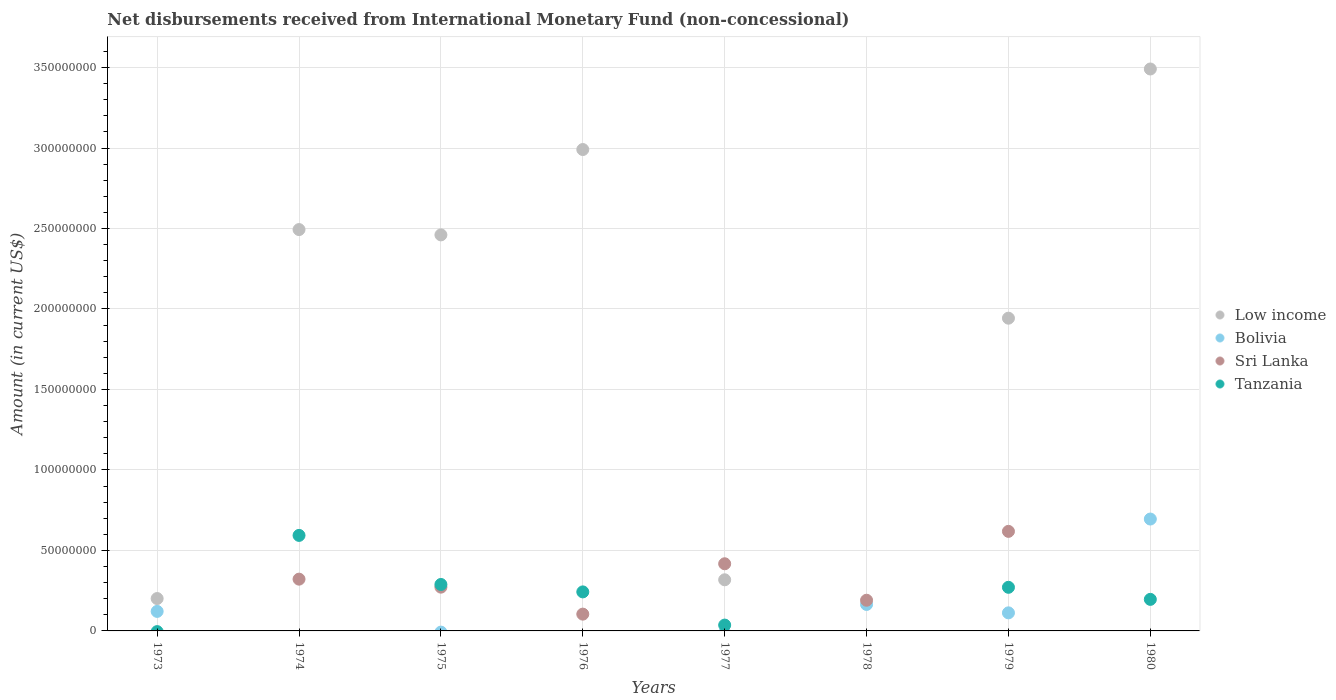How many different coloured dotlines are there?
Provide a succinct answer. 4. Is the number of dotlines equal to the number of legend labels?
Your answer should be very brief. No. What is the amount of disbursements received from International Monetary Fund in Bolivia in 1979?
Offer a terse response. 1.12e+07. Across all years, what is the maximum amount of disbursements received from International Monetary Fund in Bolivia?
Provide a short and direct response. 6.95e+07. In which year was the amount of disbursements received from International Monetary Fund in Bolivia maximum?
Give a very brief answer. 1980. What is the total amount of disbursements received from International Monetary Fund in Tanzania in the graph?
Provide a short and direct response. 1.63e+08. What is the difference between the amount of disbursements received from International Monetary Fund in Low income in 1974 and that in 1976?
Give a very brief answer. -4.97e+07. What is the difference between the amount of disbursements received from International Monetary Fund in Sri Lanka in 1973 and the amount of disbursements received from International Monetary Fund in Tanzania in 1976?
Provide a short and direct response. -2.42e+07. What is the average amount of disbursements received from International Monetary Fund in Bolivia per year?
Offer a very short reply. 1.37e+07. In the year 1978, what is the difference between the amount of disbursements received from International Monetary Fund in Sri Lanka and amount of disbursements received from International Monetary Fund in Bolivia?
Provide a succinct answer. 2.61e+06. What is the ratio of the amount of disbursements received from International Monetary Fund in Tanzania in 1974 to that in 1980?
Offer a very short reply. 3.03. What is the difference between the highest and the second highest amount of disbursements received from International Monetary Fund in Tanzania?
Make the answer very short. 3.05e+07. What is the difference between the highest and the lowest amount of disbursements received from International Monetary Fund in Bolivia?
Your answer should be very brief. 6.95e+07. Is the sum of the amount of disbursements received from International Monetary Fund in Low income in 1975 and 1980 greater than the maximum amount of disbursements received from International Monetary Fund in Tanzania across all years?
Provide a short and direct response. Yes. Is it the case that in every year, the sum of the amount of disbursements received from International Monetary Fund in Bolivia and amount of disbursements received from International Monetary Fund in Low income  is greater than the amount of disbursements received from International Monetary Fund in Sri Lanka?
Keep it short and to the point. No. Is the amount of disbursements received from International Monetary Fund in Bolivia strictly less than the amount of disbursements received from International Monetary Fund in Low income over the years?
Offer a very short reply. No. How many dotlines are there?
Provide a short and direct response. 4. What is the difference between two consecutive major ticks on the Y-axis?
Your answer should be very brief. 5.00e+07. Does the graph contain any zero values?
Provide a short and direct response. Yes. Does the graph contain grids?
Your answer should be compact. Yes. Where does the legend appear in the graph?
Offer a very short reply. Center right. What is the title of the graph?
Ensure brevity in your answer.  Net disbursements received from International Monetary Fund (non-concessional). What is the Amount (in current US$) in Low income in 1973?
Your response must be concise. 2.01e+07. What is the Amount (in current US$) in Bolivia in 1973?
Offer a terse response. 1.21e+07. What is the Amount (in current US$) in Sri Lanka in 1973?
Your answer should be very brief. 0. What is the Amount (in current US$) of Low income in 1974?
Make the answer very short. 2.49e+08. What is the Amount (in current US$) in Bolivia in 1974?
Your answer should be very brief. 0. What is the Amount (in current US$) of Sri Lanka in 1974?
Offer a very short reply. 3.22e+07. What is the Amount (in current US$) in Tanzania in 1974?
Provide a short and direct response. 5.93e+07. What is the Amount (in current US$) in Low income in 1975?
Make the answer very short. 2.46e+08. What is the Amount (in current US$) of Sri Lanka in 1975?
Give a very brief answer. 2.72e+07. What is the Amount (in current US$) in Tanzania in 1975?
Provide a succinct answer. 2.89e+07. What is the Amount (in current US$) in Low income in 1976?
Your answer should be compact. 2.99e+08. What is the Amount (in current US$) in Sri Lanka in 1976?
Give a very brief answer. 1.04e+07. What is the Amount (in current US$) of Tanzania in 1976?
Offer a very short reply. 2.42e+07. What is the Amount (in current US$) in Low income in 1977?
Give a very brief answer. 3.18e+07. What is the Amount (in current US$) in Bolivia in 1977?
Make the answer very short. 0. What is the Amount (in current US$) of Sri Lanka in 1977?
Provide a short and direct response. 4.17e+07. What is the Amount (in current US$) in Tanzania in 1977?
Your answer should be very brief. 3.63e+06. What is the Amount (in current US$) in Bolivia in 1978?
Offer a very short reply. 1.64e+07. What is the Amount (in current US$) of Sri Lanka in 1978?
Give a very brief answer. 1.91e+07. What is the Amount (in current US$) of Tanzania in 1978?
Provide a succinct answer. 0. What is the Amount (in current US$) in Low income in 1979?
Offer a terse response. 1.94e+08. What is the Amount (in current US$) in Bolivia in 1979?
Your response must be concise. 1.12e+07. What is the Amount (in current US$) in Sri Lanka in 1979?
Your answer should be compact. 6.18e+07. What is the Amount (in current US$) in Tanzania in 1979?
Provide a succinct answer. 2.71e+07. What is the Amount (in current US$) in Low income in 1980?
Provide a succinct answer. 3.49e+08. What is the Amount (in current US$) of Bolivia in 1980?
Your answer should be compact. 6.95e+07. What is the Amount (in current US$) in Tanzania in 1980?
Give a very brief answer. 1.96e+07. Across all years, what is the maximum Amount (in current US$) of Low income?
Give a very brief answer. 3.49e+08. Across all years, what is the maximum Amount (in current US$) in Bolivia?
Provide a succinct answer. 6.95e+07. Across all years, what is the maximum Amount (in current US$) in Sri Lanka?
Provide a succinct answer. 6.18e+07. Across all years, what is the maximum Amount (in current US$) in Tanzania?
Ensure brevity in your answer.  5.93e+07. Across all years, what is the minimum Amount (in current US$) in Low income?
Give a very brief answer. 0. Across all years, what is the minimum Amount (in current US$) of Bolivia?
Make the answer very short. 0. Across all years, what is the minimum Amount (in current US$) in Sri Lanka?
Provide a short and direct response. 0. Across all years, what is the minimum Amount (in current US$) of Tanzania?
Your answer should be very brief. 0. What is the total Amount (in current US$) of Low income in the graph?
Offer a very short reply. 1.39e+09. What is the total Amount (in current US$) in Bolivia in the graph?
Provide a succinct answer. 1.09e+08. What is the total Amount (in current US$) of Sri Lanka in the graph?
Offer a very short reply. 1.92e+08. What is the total Amount (in current US$) in Tanzania in the graph?
Ensure brevity in your answer.  1.63e+08. What is the difference between the Amount (in current US$) of Low income in 1973 and that in 1974?
Give a very brief answer. -2.29e+08. What is the difference between the Amount (in current US$) of Low income in 1973 and that in 1975?
Provide a succinct answer. -2.26e+08. What is the difference between the Amount (in current US$) of Low income in 1973 and that in 1976?
Ensure brevity in your answer.  -2.79e+08. What is the difference between the Amount (in current US$) of Low income in 1973 and that in 1977?
Offer a terse response. -1.17e+07. What is the difference between the Amount (in current US$) of Bolivia in 1973 and that in 1978?
Offer a very short reply. -4.32e+06. What is the difference between the Amount (in current US$) in Low income in 1973 and that in 1979?
Keep it short and to the point. -1.74e+08. What is the difference between the Amount (in current US$) in Bolivia in 1973 and that in 1979?
Your response must be concise. 8.99e+05. What is the difference between the Amount (in current US$) in Low income in 1973 and that in 1980?
Make the answer very short. -3.29e+08. What is the difference between the Amount (in current US$) in Bolivia in 1973 and that in 1980?
Offer a terse response. -5.74e+07. What is the difference between the Amount (in current US$) in Low income in 1974 and that in 1975?
Your response must be concise. 3.30e+06. What is the difference between the Amount (in current US$) in Sri Lanka in 1974 and that in 1975?
Offer a terse response. 4.97e+06. What is the difference between the Amount (in current US$) of Tanzania in 1974 and that in 1975?
Ensure brevity in your answer.  3.05e+07. What is the difference between the Amount (in current US$) of Low income in 1974 and that in 1976?
Provide a short and direct response. -4.97e+07. What is the difference between the Amount (in current US$) in Sri Lanka in 1974 and that in 1976?
Offer a terse response. 2.17e+07. What is the difference between the Amount (in current US$) in Tanzania in 1974 and that in 1976?
Your answer should be very brief. 3.51e+07. What is the difference between the Amount (in current US$) of Low income in 1974 and that in 1977?
Give a very brief answer. 2.18e+08. What is the difference between the Amount (in current US$) in Sri Lanka in 1974 and that in 1977?
Give a very brief answer. -9.56e+06. What is the difference between the Amount (in current US$) of Tanzania in 1974 and that in 1977?
Your answer should be compact. 5.57e+07. What is the difference between the Amount (in current US$) of Sri Lanka in 1974 and that in 1978?
Offer a terse response. 1.31e+07. What is the difference between the Amount (in current US$) in Low income in 1974 and that in 1979?
Provide a succinct answer. 5.50e+07. What is the difference between the Amount (in current US$) of Sri Lanka in 1974 and that in 1979?
Offer a terse response. -2.97e+07. What is the difference between the Amount (in current US$) in Tanzania in 1974 and that in 1979?
Provide a succinct answer. 3.22e+07. What is the difference between the Amount (in current US$) of Low income in 1974 and that in 1980?
Make the answer very short. -9.98e+07. What is the difference between the Amount (in current US$) in Tanzania in 1974 and that in 1980?
Your response must be concise. 3.97e+07. What is the difference between the Amount (in current US$) of Low income in 1975 and that in 1976?
Your answer should be very brief. -5.30e+07. What is the difference between the Amount (in current US$) of Sri Lanka in 1975 and that in 1976?
Provide a succinct answer. 1.68e+07. What is the difference between the Amount (in current US$) in Tanzania in 1975 and that in 1976?
Your response must be concise. 4.61e+06. What is the difference between the Amount (in current US$) in Low income in 1975 and that in 1977?
Ensure brevity in your answer.  2.14e+08. What is the difference between the Amount (in current US$) in Sri Lanka in 1975 and that in 1977?
Keep it short and to the point. -1.45e+07. What is the difference between the Amount (in current US$) of Tanzania in 1975 and that in 1977?
Offer a very short reply. 2.52e+07. What is the difference between the Amount (in current US$) in Sri Lanka in 1975 and that in 1978?
Your answer should be very brief. 8.14e+06. What is the difference between the Amount (in current US$) in Low income in 1975 and that in 1979?
Your answer should be compact. 5.17e+07. What is the difference between the Amount (in current US$) in Sri Lanka in 1975 and that in 1979?
Keep it short and to the point. -3.47e+07. What is the difference between the Amount (in current US$) in Tanzania in 1975 and that in 1979?
Give a very brief answer. 1.76e+06. What is the difference between the Amount (in current US$) of Low income in 1975 and that in 1980?
Keep it short and to the point. -1.03e+08. What is the difference between the Amount (in current US$) of Tanzania in 1975 and that in 1980?
Offer a terse response. 9.26e+06. What is the difference between the Amount (in current US$) of Low income in 1976 and that in 1977?
Provide a succinct answer. 2.67e+08. What is the difference between the Amount (in current US$) in Sri Lanka in 1976 and that in 1977?
Give a very brief answer. -3.13e+07. What is the difference between the Amount (in current US$) of Tanzania in 1976 and that in 1977?
Your answer should be very brief. 2.06e+07. What is the difference between the Amount (in current US$) of Sri Lanka in 1976 and that in 1978?
Offer a terse response. -8.63e+06. What is the difference between the Amount (in current US$) in Low income in 1976 and that in 1979?
Your answer should be very brief. 1.05e+08. What is the difference between the Amount (in current US$) of Sri Lanka in 1976 and that in 1979?
Your answer should be compact. -5.14e+07. What is the difference between the Amount (in current US$) in Tanzania in 1976 and that in 1979?
Provide a short and direct response. -2.85e+06. What is the difference between the Amount (in current US$) of Low income in 1976 and that in 1980?
Your answer should be compact. -5.00e+07. What is the difference between the Amount (in current US$) of Tanzania in 1976 and that in 1980?
Your response must be concise. 4.64e+06. What is the difference between the Amount (in current US$) of Sri Lanka in 1977 and that in 1978?
Your answer should be very brief. 2.27e+07. What is the difference between the Amount (in current US$) in Low income in 1977 and that in 1979?
Your response must be concise. -1.63e+08. What is the difference between the Amount (in current US$) of Sri Lanka in 1977 and that in 1979?
Your answer should be very brief. -2.01e+07. What is the difference between the Amount (in current US$) in Tanzania in 1977 and that in 1979?
Keep it short and to the point. -2.35e+07. What is the difference between the Amount (in current US$) in Low income in 1977 and that in 1980?
Keep it short and to the point. -3.17e+08. What is the difference between the Amount (in current US$) in Tanzania in 1977 and that in 1980?
Your answer should be compact. -1.60e+07. What is the difference between the Amount (in current US$) of Bolivia in 1978 and that in 1979?
Your answer should be very brief. 5.22e+06. What is the difference between the Amount (in current US$) in Sri Lanka in 1978 and that in 1979?
Offer a terse response. -4.28e+07. What is the difference between the Amount (in current US$) of Bolivia in 1978 and that in 1980?
Ensure brevity in your answer.  -5.31e+07. What is the difference between the Amount (in current US$) of Low income in 1979 and that in 1980?
Provide a short and direct response. -1.55e+08. What is the difference between the Amount (in current US$) of Bolivia in 1979 and that in 1980?
Ensure brevity in your answer.  -5.83e+07. What is the difference between the Amount (in current US$) of Tanzania in 1979 and that in 1980?
Make the answer very short. 7.50e+06. What is the difference between the Amount (in current US$) in Low income in 1973 and the Amount (in current US$) in Sri Lanka in 1974?
Keep it short and to the point. -1.20e+07. What is the difference between the Amount (in current US$) of Low income in 1973 and the Amount (in current US$) of Tanzania in 1974?
Give a very brief answer. -3.92e+07. What is the difference between the Amount (in current US$) in Bolivia in 1973 and the Amount (in current US$) in Sri Lanka in 1974?
Offer a very short reply. -2.00e+07. What is the difference between the Amount (in current US$) of Bolivia in 1973 and the Amount (in current US$) of Tanzania in 1974?
Your response must be concise. -4.72e+07. What is the difference between the Amount (in current US$) in Low income in 1973 and the Amount (in current US$) in Sri Lanka in 1975?
Your answer should be very brief. -7.08e+06. What is the difference between the Amount (in current US$) in Low income in 1973 and the Amount (in current US$) in Tanzania in 1975?
Provide a short and direct response. -8.74e+06. What is the difference between the Amount (in current US$) of Bolivia in 1973 and the Amount (in current US$) of Sri Lanka in 1975?
Your answer should be compact. -1.51e+07. What is the difference between the Amount (in current US$) in Bolivia in 1973 and the Amount (in current US$) in Tanzania in 1975?
Provide a succinct answer. -1.67e+07. What is the difference between the Amount (in current US$) of Low income in 1973 and the Amount (in current US$) of Sri Lanka in 1976?
Your answer should be very brief. 9.68e+06. What is the difference between the Amount (in current US$) of Low income in 1973 and the Amount (in current US$) of Tanzania in 1976?
Your answer should be compact. -4.13e+06. What is the difference between the Amount (in current US$) of Bolivia in 1973 and the Amount (in current US$) of Sri Lanka in 1976?
Provide a succinct answer. 1.70e+06. What is the difference between the Amount (in current US$) in Bolivia in 1973 and the Amount (in current US$) in Tanzania in 1976?
Provide a short and direct response. -1.21e+07. What is the difference between the Amount (in current US$) in Low income in 1973 and the Amount (in current US$) in Sri Lanka in 1977?
Provide a short and direct response. -2.16e+07. What is the difference between the Amount (in current US$) in Low income in 1973 and the Amount (in current US$) in Tanzania in 1977?
Your answer should be compact. 1.65e+07. What is the difference between the Amount (in current US$) in Bolivia in 1973 and the Amount (in current US$) in Sri Lanka in 1977?
Your answer should be compact. -2.96e+07. What is the difference between the Amount (in current US$) in Bolivia in 1973 and the Amount (in current US$) in Tanzania in 1977?
Make the answer very short. 8.50e+06. What is the difference between the Amount (in current US$) in Low income in 1973 and the Amount (in current US$) in Bolivia in 1978?
Keep it short and to the point. 3.67e+06. What is the difference between the Amount (in current US$) of Low income in 1973 and the Amount (in current US$) of Sri Lanka in 1978?
Offer a very short reply. 1.06e+06. What is the difference between the Amount (in current US$) of Bolivia in 1973 and the Amount (in current US$) of Sri Lanka in 1978?
Provide a succinct answer. -6.93e+06. What is the difference between the Amount (in current US$) in Low income in 1973 and the Amount (in current US$) in Bolivia in 1979?
Offer a very short reply. 8.88e+06. What is the difference between the Amount (in current US$) in Low income in 1973 and the Amount (in current US$) in Sri Lanka in 1979?
Offer a terse response. -4.17e+07. What is the difference between the Amount (in current US$) of Low income in 1973 and the Amount (in current US$) of Tanzania in 1979?
Provide a short and direct response. -6.98e+06. What is the difference between the Amount (in current US$) of Bolivia in 1973 and the Amount (in current US$) of Sri Lanka in 1979?
Offer a very short reply. -4.97e+07. What is the difference between the Amount (in current US$) of Bolivia in 1973 and the Amount (in current US$) of Tanzania in 1979?
Your answer should be very brief. -1.50e+07. What is the difference between the Amount (in current US$) of Low income in 1973 and the Amount (in current US$) of Bolivia in 1980?
Provide a short and direct response. -4.94e+07. What is the difference between the Amount (in current US$) in Low income in 1973 and the Amount (in current US$) in Tanzania in 1980?
Offer a very short reply. 5.13e+05. What is the difference between the Amount (in current US$) in Bolivia in 1973 and the Amount (in current US$) in Tanzania in 1980?
Provide a succinct answer. -7.47e+06. What is the difference between the Amount (in current US$) of Low income in 1974 and the Amount (in current US$) of Sri Lanka in 1975?
Your answer should be compact. 2.22e+08. What is the difference between the Amount (in current US$) in Low income in 1974 and the Amount (in current US$) in Tanzania in 1975?
Keep it short and to the point. 2.20e+08. What is the difference between the Amount (in current US$) in Sri Lanka in 1974 and the Amount (in current US$) in Tanzania in 1975?
Offer a terse response. 3.30e+06. What is the difference between the Amount (in current US$) in Low income in 1974 and the Amount (in current US$) in Sri Lanka in 1976?
Your answer should be very brief. 2.39e+08. What is the difference between the Amount (in current US$) of Low income in 1974 and the Amount (in current US$) of Tanzania in 1976?
Your answer should be very brief. 2.25e+08. What is the difference between the Amount (in current US$) in Sri Lanka in 1974 and the Amount (in current US$) in Tanzania in 1976?
Offer a very short reply. 7.92e+06. What is the difference between the Amount (in current US$) in Low income in 1974 and the Amount (in current US$) in Sri Lanka in 1977?
Give a very brief answer. 2.08e+08. What is the difference between the Amount (in current US$) in Low income in 1974 and the Amount (in current US$) in Tanzania in 1977?
Give a very brief answer. 2.46e+08. What is the difference between the Amount (in current US$) in Sri Lanka in 1974 and the Amount (in current US$) in Tanzania in 1977?
Offer a terse response. 2.85e+07. What is the difference between the Amount (in current US$) of Low income in 1974 and the Amount (in current US$) of Bolivia in 1978?
Offer a very short reply. 2.33e+08. What is the difference between the Amount (in current US$) of Low income in 1974 and the Amount (in current US$) of Sri Lanka in 1978?
Offer a terse response. 2.30e+08. What is the difference between the Amount (in current US$) of Low income in 1974 and the Amount (in current US$) of Bolivia in 1979?
Your answer should be compact. 2.38e+08. What is the difference between the Amount (in current US$) of Low income in 1974 and the Amount (in current US$) of Sri Lanka in 1979?
Give a very brief answer. 1.87e+08. What is the difference between the Amount (in current US$) in Low income in 1974 and the Amount (in current US$) in Tanzania in 1979?
Your response must be concise. 2.22e+08. What is the difference between the Amount (in current US$) in Sri Lanka in 1974 and the Amount (in current US$) in Tanzania in 1979?
Your response must be concise. 5.07e+06. What is the difference between the Amount (in current US$) of Low income in 1974 and the Amount (in current US$) of Bolivia in 1980?
Make the answer very short. 1.80e+08. What is the difference between the Amount (in current US$) of Low income in 1974 and the Amount (in current US$) of Tanzania in 1980?
Your answer should be compact. 2.30e+08. What is the difference between the Amount (in current US$) in Sri Lanka in 1974 and the Amount (in current US$) in Tanzania in 1980?
Your answer should be very brief. 1.26e+07. What is the difference between the Amount (in current US$) of Low income in 1975 and the Amount (in current US$) of Sri Lanka in 1976?
Provide a short and direct response. 2.36e+08. What is the difference between the Amount (in current US$) of Low income in 1975 and the Amount (in current US$) of Tanzania in 1976?
Offer a terse response. 2.22e+08. What is the difference between the Amount (in current US$) in Sri Lanka in 1975 and the Amount (in current US$) in Tanzania in 1976?
Offer a terse response. 2.95e+06. What is the difference between the Amount (in current US$) of Low income in 1975 and the Amount (in current US$) of Sri Lanka in 1977?
Your answer should be very brief. 2.04e+08. What is the difference between the Amount (in current US$) of Low income in 1975 and the Amount (in current US$) of Tanzania in 1977?
Your response must be concise. 2.42e+08. What is the difference between the Amount (in current US$) in Sri Lanka in 1975 and the Amount (in current US$) in Tanzania in 1977?
Your answer should be very brief. 2.36e+07. What is the difference between the Amount (in current US$) of Low income in 1975 and the Amount (in current US$) of Bolivia in 1978?
Make the answer very short. 2.30e+08. What is the difference between the Amount (in current US$) in Low income in 1975 and the Amount (in current US$) in Sri Lanka in 1978?
Offer a terse response. 2.27e+08. What is the difference between the Amount (in current US$) in Low income in 1975 and the Amount (in current US$) in Bolivia in 1979?
Provide a succinct answer. 2.35e+08. What is the difference between the Amount (in current US$) of Low income in 1975 and the Amount (in current US$) of Sri Lanka in 1979?
Offer a terse response. 1.84e+08. What is the difference between the Amount (in current US$) of Low income in 1975 and the Amount (in current US$) of Tanzania in 1979?
Offer a very short reply. 2.19e+08. What is the difference between the Amount (in current US$) in Sri Lanka in 1975 and the Amount (in current US$) in Tanzania in 1979?
Ensure brevity in your answer.  9.80e+04. What is the difference between the Amount (in current US$) of Low income in 1975 and the Amount (in current US$) of Bolivia in 1980?
Your answer should be compact. 1.77e+08. What is the difference between the Amount (in current US$) of Low income in 1975 and the Amount (in current US$) of Tanzania in 1980?
Keep it short and to the point. 2.26e+08. What is the difference between the Amount (in current US$) of Sri Lanka in 1975 and the Amount (in current US$) of Tanzania in 1980?
Make the answer very short. 7.59e+06. What is the difference between the Amount (in current US$) in Low income in 1976 and the Amount (in current US$) in Sri Lanka in 1977?
Offer a very short reply. 2.57e+08. What is the difference between the Amount (in current US$) in Low income in 1976 and the Amount (in current US$) in Tanzania in 1977?
Offer a very short reply. 2.95e+08. What is the difference between the Amount (in current US$) in Sri Lanka in 1976 and the Amount (in current US$) in Tanzania in 1977?
Keep it short and to the point. 6.80e+06. What is the difference between the Amount (in current US$) in Low income in 1976 and the Amount (in current US$) in Bolivia in 1978?
Your answer should be compact. 2.83e+08. What is the difference between the Amount (in current US$) in Low income in 1976 and the Amount (in current US$) in Sri Lanka in 1978?
Provide a short and direct response. 2.80e+08. What is the difference between the Amount (in current US$) in Low income in 1976 and the Amount (in current US$) in Bolivia in 1979?
Make the answer very short. 2.88e+08. What is the difference between the Amount (in current US$) of Low income in 1976 and the Amount (in current US$) of Sri Lanka in 1979?
Your answer should be compact. 2.37e+08. What is the difference between the Amount (in current US$) in Low income in 1976 and the Amount (in current US$) in Tanzania in 1979?
Provide a succinct answer. 2.72e+08. What is the difference between the Amount (in current US$) in Sri Lanka in 1976 and the Amount (in current US$) in Tanzania in 1979?
Keep it short and to the point. -1.67e+07. What is the difference between the Amount (in current US$) of Low income in 1976 and the Amount (in current US$) of Bolivia in 1980?
Offer a terse response. 2.30e+08. What is the difference between the Amount (in current US$) of Low income in 1976 and the Amount (in current US$) of Tanzania in 1980?
Make the answer very short. 2.79e+08. What is the difference between the Amount (in current US$) of Sri Lanka in 1976 and the Amount (in current US$) of Tanzania in 1980?
Your answer should be very brief. -9.17e+06. What is the difference between the Amount (in current US$) of Low income in 1977 and the Amount (in current US$) of Bolivia in 1978?
Provide a succinct answer. 1.53e+07. What is the difference between the Amount (in current US$) of Low income in 1977 and the Amount (in current US$) of Sri Lanka in 1978?
Give a very brief answer. 1.27e+07. What is the difference between the Amount (in current US$) in Low income in 1977 and the Amount (in current US$) in Bolivia in 1979?
Offer a very short reply. 2.05e+07. What is the difference between the Amount (in current US$) in Low income in 1977 and the Amount (in current US$) in Sri Lanka in 1979?
Give a very brief answer. -3.01e+07. What is the difference between the Amount (in current US$) in Low income in 1977 and the Amount (in current US$) in Tanzania in 1979?
Your answer should be compact. 4.67e+06. What is the difference between the Amount (in current US$) of Sri Lanka in 1977 and the Amount (in current US$) of Tanzania in 1979?
Ensure brevity in your answer.  1.46e+07. What is the difference between the Amount (in current US$) in Low income in 1977 and the Amount (in current US$) in Bolivia in 1980?
Your answer should be compact. -3.77e+07. What is the difference between the Amount (in current US$) in Low income in 1977 and the Amount (in current US$) in Tanzania in 1980?
Provide a short and direct response. 1.22e+07. What is the difference between the Amount (in current US$) of Sri Lanka in 1977 and the Amount (in current US$) of Tanzania in 1980?
Give a very brief answer. 2.21e+07. What is the difference between the Amount (in current US$) of Bolivia in 1978 and the Amount (in current US$) of Sri Lanka in 1979?
Offer a very short reply. -4.54e+07. What is the difference between the Amount (in current US$) in Bolivia in 1978 and the Amount (in current US$) in Tanzania in 1979?
Offer a terse response. -1.07e+07. What is the difference between the Amount (in current US$) in Sri Lanka in 1978 and the Amount (in current US$) in Tanzania in 1979?
Ensure brevity in your answer.  -8.04e+06. What is the difference between the Amount (in current US$) in Bolivia in 1978 and the Amount (in current US$) in Tanzania in 1980?
Offer a terse response. -3.16e+06. What is the difference between the Amount (in current US$) of Sri Lanka in 1978 and the Amount (in current US$) of Tanzania in 1980?
Provide a succinct answer. -5.42e+05. What is the difference between the Amount (in current US$) in Low income in 1979 and the Amount (in current US$) in Bolivia in 1980?
Provide a short and direct response. 1.25e+08. What is the difference between the Amount (in current US$) in Low income in 1979 and the Amount (in current US$) in Tanzania in 1980?
Your answer should be very brief. 1.75e+08. What is the difference between the Amount (in current US$) in Bolivia in 1979 and the Amount (in current US$) in Tanzania in 1980?
Give a very brief answer. -8.37e+06. What is the difference between the Amount (in current US$) of Sri Lanka in 1979 and the Amount (in current US$) of Tanzania in 1980?
Make the answer very short. 4.22e+07. What is the average Amount (in current US$) in Low income per year?
Your answer should be compact. 1.74e+08. What is the average Amount (in current US$) of Bolivia per year?
Make the answer very short. 1.37e+07. What is the average Amount (in current US$) in Sri Lanka per year?
Your answer should be compact. 2.41e+07. What is the average Amount (in current US$) in Tanzania per year?
Keep it short and to the point. 2.03e+07. In the year 1973, what is the difference between the Amount (in current US$) of Low income and Amount (in current US$) of Bolivia?
Keep it short and to the point. 7.99e+06. In the year 1974, what is the difference between the Amount (in current US$) in Low income and Amount (in current US$) in Sri Lanka?
Give a very brief answer. 2.17e+08. In the year 1974, what is the difference between the Amount (in current US$) of Low income and Amount (in current US$) of Tanzania?
Offer a very short reply. 1.90e+08. In the year 1974, what is the difference between the Amount (in current US$) in Sri Lanka and Amount (in current US$) in Tanzania?
Keep it short and to the point. -2.72e+07. In the year 1975, what is the difference between the Amount (in current US$) of Low income and Amount (in current US$) of Sri Lanka?
Provide a short and direct response. 2.19e+08. In the year 1975, what is the difference between the Amount (in current US$) of Low income and Amount (in current US$) of Tanzania?
Your response must be concise. 2.17e+08. In the year 1975, what is the difference between the Amount (in current US$) of Sri Lanka and Amount (in current US$) of Tanzania?
Your answer should be very brief. -1.66e+06. In the year 1976, what is the difference between the Amount (in current US$) in Low income and Amount (in current US$) in Sri Lanka?
Give a very brief answer. 2.89e+08. In the year 1976, what is the difference between the Amount (in current US$) in Low income and Amount (in current US$) in Tanzania?
Offer a terse response. 2.75e+08. In the year 1976, what is the difference between the Amount (in current US$) of Sri Lanka and Amount (in current US$) of Tanzania?
Make the answer very short. -1.38e+07. In the year 1977, what is the difference between the Amount (in current US$) of Low income and Amount (in current US$) of Sri Lanka?
Your answer should be very brief. -9.95e+06. In the year 1977, what is the difference between the Amount (in current US$) in Low income and Amount (in current US$) in Tanzania?
Provide a succinct answer. 2.81e+07. In the year 1977, what is the difference between the Amount (in current US$) in Sri Lanka and Amount (in current US$) in Tanzania?
Offer a terse response. 3.81e+07. In the year 1978, what is the difference between the Amount (in current US$) of Bolivia and Amount (in current US$) of Sri Lanka?
Your response must be concise. -2.61e+06. In the year 1979, what is the difference between the Amount (in current US$) of Low income and Amount (in current US$) of Bolivia?
Keep it short and to the point. 1.83e+08. In the year 1979, what is the difference between the Amount (in current US$) of Low income and Amount (in current US$) of Sri Lanka?
Your answer should be very brief. 1.32e+08. In the year 1979, what is the difference between the Amount (in current US$) in Low income and Amount (in current US$) in Tanzania?
Keep it short and to the point. 1.67e+08. In the year 1979, what is the difference between the Amount (in current US$) of Bolivia and Amount (in current US$) of Sri Lanka?
Offer a very short reply. -5.06e+07. In the year 1979, what is the difference between the Amount (in current US$) of Bolivia and Amount (in current US$) of Tanzania?
Keep it short and to the point. -1.59e+07. In the year 1979, what is the difference between the Amount (in current US$) in Sri Lanka and Amount (in current US$) in Tanzania?
Offer a terse response. 3.48e+07. In the year 1980, what is the difference between the Amount (in current US$) in Low income and Amount (in current US$) in Bolivia?
Provide a succinct answer. 2.80e+08. In the year 1980, what is the difference between the Amount (in current US$) in Low income and Amount (in current US$) in Tanzania?
Give a very brief answer. 3.29e+08. In the year 1980, what is the difference between the Amount (in current US$) of Bolivia and Amount (in current US$) of Tanzania?
Give a very brief answer. 4.99e+07. What is the ratio of the Amount (in current US$) of Low income in 1973 to that in 1974?
Ensure brevity in your answer.  0.08. What is the ratio of the Amount (in current US$) of Low income in 1973 to that in 1975?
Your answer should be very brief. 0.08. What is the ratio of the Amount (in current US$) in Low income in 1973 to that in 1976?
Ensure brevity in your answer.  0.07. What is the ratio of the Amount (in current US$) in Low income in 1973 to that in 1977?
Keep it short and to the point. 0.63. What is the ratio of the Amount (in current US$) of Bolivia in 1973 to that in 1978?
Your response must be concise. 0.74. What is the ratio of the Amount (in current US$) of Low income in 1973 to that in 1979?
Make the answer very short. 0.1. What is the ratio of the Amount (in current US$) in Bolivia in 1973 to that in 1979?
Keep it short and to the point. 1.08. What is the ratio of the Amount (in current US$) of Low income in 1973 to that in 1980?
Ensure brevity in your answer.  0.06. What is the ratio of the Amount (in current US$) of Bolivia in 1973 to that in 1980?
Keep it short and to the point. 0.17. What is the ratio of the Amount (in current US$) of Low income in 1974 to that in 1975?
Make the answer very short. 1.01. What is the ratio of the Amount (in current US$) of Sri Lanka in 1974 to that in 1975?
Offer a very short reply. 1.18. What is the ratio of the Amount (in current US$) in Tanzania in 1974 to that in 1975?
Provide a succinct answer. 2.06. What is the ratio of the Amount (in current US$) in Low income in 1974 to that in 1976?
Your answer should be compact. 0.83. What is the ratio of the Amount (in current US$) of Sri Lanka in 1974 to that in 1976?
Keep it short and to the point. 3.08. What is the ratio of the Amount (in current US$) of Tanzania in 1974 to that in 1976?
Make the answer very short. 2.45. What is the ratio of the Amount (in current US$) of Low income in 1974 to that in 1977?
Your answer should be very brief. 7.85. What is the ratio of the Amount (in current US$) of Sri Lanka in 1974 to that in 1977?
Your answer should be compact. 0.77. What is the ratio of the Amount (in current US$) of Tanzania in 1974 to that in 1977?
Your response must be concise. 16.34. What is the ratio of the Amount (in current US$) in Sri Lanka in 1974 to that in 1978?
Offer a terse response. 1.69. What is the ratio of the Amount (in current US$) of Low income in 1974 to that in 1979?
Offer a very short reply. 1.28. What is the ratio of the Amount (in current US$) in Sri Lanka in 1974 to that in 1979?
Give a very brief answer. 0.52. What is the ratio of the Amount (in current US$) of Tanzania in 1974 to that in 1979?
Give a very brief answer. 2.19. What is the ratio of the Amount (in current US$) in Low income in 1974 to that in 1980?
Ensure brevity in your answer.  0.71. What is the ratio of the Amount (in current US$) in Tanzania in 1974 to that in 1980?
Your answer should be very brief. 3.03. What is the ratio of the Amount (in current US$) in Low income in 1975 to that in 1976?
Make the answer very short. 0.82. What is the ratio of the Amount (in current US$) in Sri Lanka in 1975 to that in 1976?
Ensure brevity in your answer.  2.61. What is the ratio of the Amount (in current US$) in Tanzania in 1975 to that in 1976?
Your answer should be very brief. 1.19. What is the ratio of the Amount (in current US$) of Low income in 1975 to that in 1977?
Your response must be concise. 7.75. What is the ratio of the Amount (in current US$) in Sri Lanka in 1975 to that in 1977?
Ensure brevity in your answer.  0.65. What is the ratio of the Amount (in current US$) in Tanzania in 1975 to that in 1977?
Keep it short and to the point. 7.95. What is the ratio of the Amount (in current US$) in Sri Lanka in 1975 to that in 1978?
Offer a terse response. 1.43. What is the ratio of the Amount (in current US$) in Low income in 1975 to that in 1979?
Your response must be concise. 1.27. What is the ratio of the Amount (in current US$) in Sri Lanka in 1975 to that in 1979?
Give a very brief answer. 0.44. What is the ratio of the Amount (in current US$) of Tanzania in 1975 to that in 1979?
Offer a terse response. 1.07. What is the ratio of the Amount (in current US$) in Low income in 1975 to that in 1980?
Your answer should be very brief. 0.7. What is the ratio of the Amount (in current US$) in Tanzania in 1975 to that in 1980?
Ensure brevity in your answer.  1.47. What is the ratio of the Amount (in current US$) in Low income in 1976 to that in 1977?
Provide a succinct answer. 9.41. What is the ratio of the Amount (in current US$) in Tanzania in 1976 to that in 1977?
Give a very brief answer. 6.68. What is the ratio of the Amount (in current US$) of Sri Lanka in 1976 to that in 1978?
Your response must be concise. 0.55. What is the ratio of the Amount (in current US$) in Low income in 1976 to that in 1979?
Keep it short and to the point. 1.54. What is the ratio of the Amount (in current US$) in Sri Lanka in 1976 to that in 1979?
Your answer should be compact. 0.17. What is the ratio of the Amount (in current US$) of Tanzania in 1976 to that in 1979?
Offer a terse response. 0.89. What is the ratio of the Amount (in current US$) in Low income in 1976 to that in 1980?
Offer a terse response. 0.86. What is the ratio of the Amount (in current US$) in Tanzania in 1976 to that in 1980?
Give a very brief answer. 1.24. What is the ratio of the Amount (in current US$) of Sri Lanka in 1977 to that in 1978?
Your response must be concise. 2.19. What is the ratio of the Amount (in current US$) in Low income in 1977 to that in 1979?
Your response must be concise. 0.16. What is the ratio of the Amount (in current US$) in Sri Lanka in 1977 to that in 1979?
Offer a terse response. 0.67. What is the ratio of the Amount (in current US$) of Tanzania in 1977 to that in 1979?
Your answer should be very brief. 0.13. What is the ratio of the Amount (in current US$) of Low income in 1977 to that in 1980?
Offer a terse response. 0.09. What is the ratio of the Amount (in current US$) of Tanzania in 1977 to that in 1980?
Give a very brief answer. 0.19. What is the ratio of the Amount (in current US$) in Bolivia in 1978 to that in 1979?
Offer a terse response. 1.46. What is the ratio of the Amount (in current US$) in Sri Lanka in 1978 to that in 1979?
Your response must be concise. 0.31. What is the ratio of the Amount (in current US$) in Bolivia in 1978 to that in 1980?
Your response must be concise. 0.24. What is the ratio of the Amount (in current US$) in Low income in 1979 to that in 1980?
Ensure brevity in your answer.  0.56. What is the ratio of the Amount (in current US$) of Bolivia in 1979 to that in 1980?
Keep it short and to the point. 0.16. What is the ratio of the Amount (in current US$) in Tanzania in 1979 to that in 1980?
Make the answer very short. 1.38. What is the difference between the highest and the second highest Amount (in current US$) of Low income?
Give a very brief answer. 5.00e+07. What is the difference between the highest and the second highest Amount (in current US$) of Bolivia?
Your answer should be very brief. 5.31e+07. What is the difference between the highest and the second highest Amount (in current US$) in Sri Lanka?
Offer a very short reply. 2.01e+07. What is the difference between the highest and the second highest Amount (in current US$) of Tanzania?
Give a very brief answer. 3.05e+07. What is the difference between the highest and the lowest Amount (in current US$) in Low income?
Provide a succinct answer. 3.49e+08. What is the difference between the highest and the lowest Amount (in current US$) in Bolivia?
Give a very brief answer. 6.95e+07. What is the difference between the highest and the lowest Amount (in current US$) in Sri Lanka?
Give a very brief answer. 6.18e+07. What is the difference between the highest and the lowest Amount (in current US$) of Tanzania?
Provide a short and direct response. 5.93e+07. 